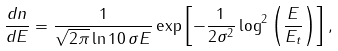Convert formula to latex. <formula><loc_0><loc_0><loc_500><loc_500>\frac { d n } { d E } = \frac { 1 } { \sqrt { 2 \pi } \ln { 1 0 } \, \sigma E } \exp { \left [ - \frac { 1 } { 2 \sigma ^ { 2 } } \log ^ { 2 } { \left ( \frac { E } { E _ { t } } \right ) } \right ] } \, ,</formula> 